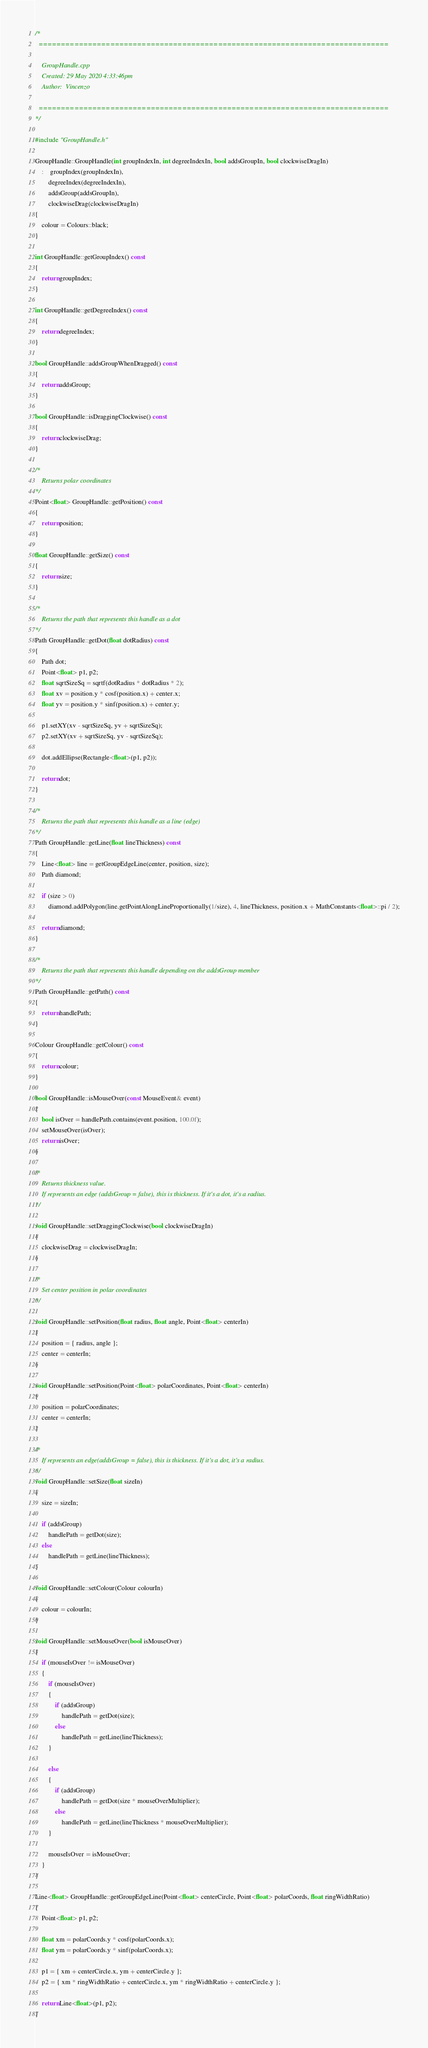Convert code to text. <code><loc_0><loc_0><loc_500><loc_500><_C++_>/*
  ==============================================================================

    GroupHandle.cpp
    Created: 29 May 2020 4:33:46pm
    Author:  Vincenzo

  ==============================================================================
*/

#include "GroupHandle.h"

GroupHandle::GroupHandle(int groupIndexIn, int degreeIndexIn, bool addsGroupIn, bool clockwiseDragIn)
	:	groupIndex(groupIndexIn),
		degreeIndex(degreeIndexIn),
		addsGroup(addsGroupIn),
		clockwiseDrag(clockwiseDragIn)
{
	colour = Colours::black;
}

int GroupHandle::getGroupIndex() const
{
	return groupIndex;
}

int GroupHandle::getDegreeIndex() const
{
	return degreeIndex;
}

bool GroupHandle::addsGroupWhenDragged() const
{
	return addsGroup;
}

bool GroupHandle::isDraggingClockwise() const
{
	return clockwiseDrag;
}

/*
	Returns polar coordinates
*/
Point<float> GroupHandle::getPosition() const
{
	return position;
}

float GroupHandle::getSize() const
{
	return size;
}

/*
	Returns the path that represents this handle as a dot
*/
Path GroupHandle::getDot(float dotRadius) const
{
	Path dot;
	Point<float> p1, p2;
	float sqrtSizeSq = sqrtf(dotRadius * dotRadius * 2);
	float xv = position.y * cosf(position.x) + center.x;
	float yv = position.y * sinf(position.x) + center.y;

	p1.setXY(xv - sqrtSizeSq, yv + sqrtSizeSq);
	p2.setXY(xv + sqrtSizeSq, yv - sqrtSizeSq);

	dot.addEllipse(Rectangle<float>(p1, p2));

	return dot;
}

/*
	Returns the path that represents this handle as a line (edge)
*/
Path GroupHandle::getLine(float lineThickness) const
{
	Line<float> line = getGroupEdgeLine(center, position, size);
	Path diamond;

	if (size > 0)
		diamond.addPolygon(line.getPointAlongLineProportionally(1/size), 4, lineThickness, position.x + MathConstants<float>::pi / 2);

	return diamond;
}

/*
	Returns the path that represents this handle depending on the addsGroup member
*/
Path GroupHandle::getPath() const
{
	return handlePath;
}

Colour GroupHandle::getColour() const
{
	return colour;
}

bool GroupHandle::isMouseOver(const MouseEvent& event)
{
	bool isOver = handlePath.contains(event.position, 100.0f);
	setMouseOver(isOver);
	return isOver;
}

/*
	Returns thickness value.
	If represents an edge (addsGroup = false), this is thickness. If it's a dot, it's a radius.
*/

void GroupHandle::setDraggingClockwise(bool clockwiseDragIn)
{
	clockwiseDrag = clockwiseDragIn;
}

/*
	Set center position in polar coordinates
*/

void GroupHandle::setPosition(float radius, float angle, Point<float> centerIn)
{
	position = { radius, angle };
	center = centerIn;
}

void GroupHandle::setPosition(Point<float> polarCoordinates, Point<float> centerIn)
{
	position = polarCoordinates;
	center = centerIn;
}

/*
	If represents an edge(addsGroup = false), this is thickness. If it's a dot, it's a radius.
*/
void GroupHandle::setSize(float sizeIn)
{
	size = sizeIn;

	if (addsGroup)
		handlePath = getDot(size);
	else
		handlePath = getLine(lineThickness);
}

void GroupHandle::setColour(Colour colourIn)
{
	colour = colourIn;
}

void GroupHandle::setMouseOver(bool isMouseOver)
{
	if (mouseIsOver != isMouseOver)
	{
		if (mouseIsOver)
		{
			if (addsGroup)
				handlePath = getDot(size);
			else
				handlePath = getLine(lineThickness);
		}

		else
		{
			if (addsGroup)
				handlePath = getDot(size * mouseOverMultiplier);
			else
				handlePath = getLine(lineThickness * mouseOverMultiplier);
		}

		mouseIsOver = isMouseOver;
	}
}

Line<float> GroupHandle::getGroupEdgeLine(Point<float> centerCircle, Point<float> polarCoords, float ringWidthRatio)
{
	Point<float> p1, p2;

	float xm = polarCoords.y * cosf(polarCoords.x);
	float ym = polarCoords.y * sinf(polarCoords.x);

	p1 = { xm + centerCircle.x, ym + centerCircle.y };
	p2 = { xm * ringWidthRatio + centerCircle.x, ym * ringWidthRatio + centerCircle.y };
	
	return Line<float>(p1, p2);
}</code> 